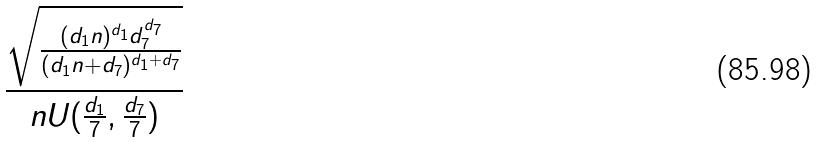Convert formula to latex. <formula><loc_0><loc_0><loc_500><loc_500>\frac { \sqrt { \frac { ( d _ { 1 } n ) ^ { d _ { 1 } } d _ { 7 } ^ { d _ { 7 } } } { ( d _ { 1 } n + d _ { 7 } ) ^ { d _ { 1 } + d _ { 7 } } } } } { n U ( \frac { d _ { 1 } } { 7 } , \frac { d _ { 7 } } { 7 } ) }</formula> 